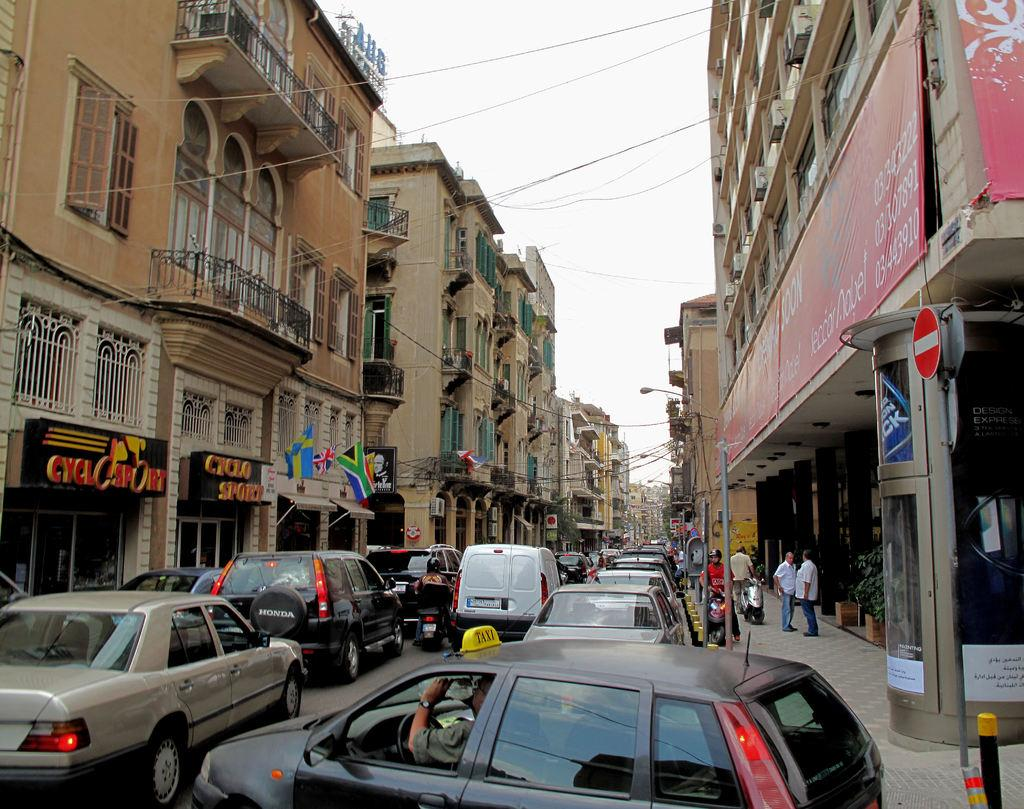What type of structures can be seen in the image? There are buildings in the image. What is happening on the road in the image? Cars and vehicles are present on the road in the image. What is visible at the top of the image? There is sky visible at the top of the image. What else can be seen in the image besides buildings and vehicles? There are wires in the image. Can you hear the pump running in the image? There is no pump present in the image, so it is not possible to hear it running. 